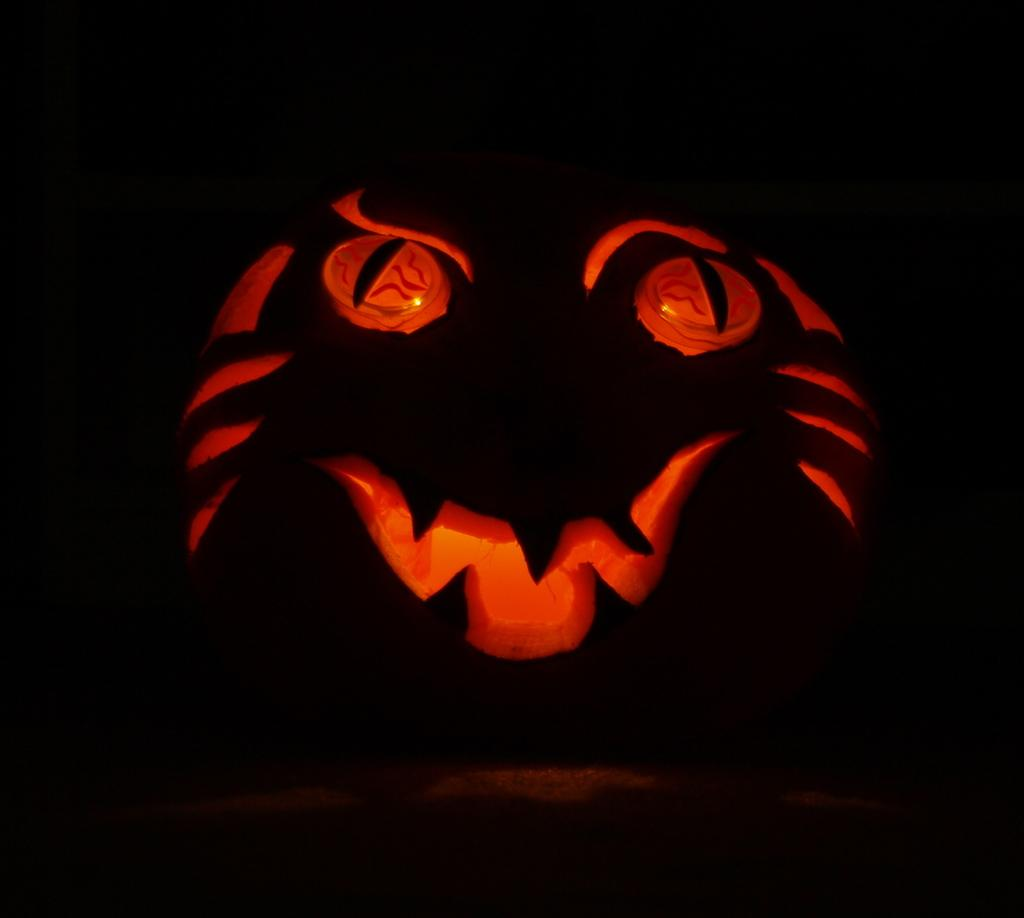What is the main object in the image? There is a halloween pumpkin lantern in the image. What can be observed about the lighting in the image? The background of the image is dark. Can you see any jellyfish swimming in the image? There are no jellyfish present in the image; it features a halloween pumpkin lantern. What type of feather is used to decorate the pumpkin in the image? There is no feather used to decorate the pumpkin in the image; it is a simple halloween pumpkin lantern. 